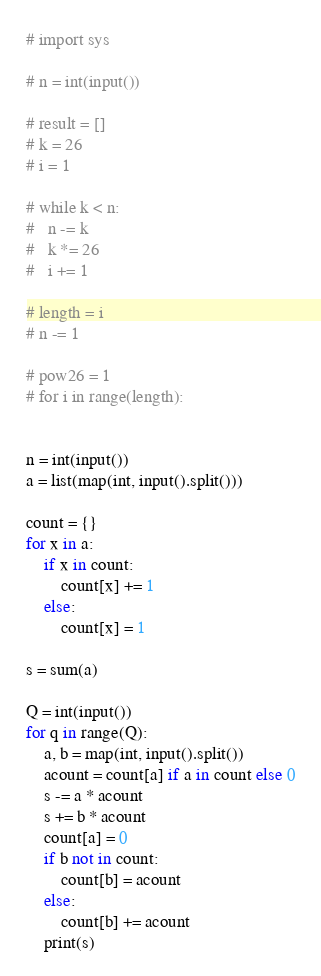<code> <loc_0><loc_0><loc_500><loc_500><_Python_># import sys

# n = int(input())

# result = []
# k = 26
# i = 1

# while k < n:
# 	n -= k
# 	k *= 26
# 	i += 1

# length = i
# n -= 1

# pow26 = 1
# for i in range(length):


n = int(input())
a = list(map(int, input().split()))

count = {}
for x in a:
	if x in count:
		count[x] += 1
	else:
		count[x] = 1

s = sum(a)

Q = int(input())
for q in range(Q):
	a, b = map(int, input().split())
	acount = count[a] if a in count else 0
	s -= a * acount 
	s += b * acount
	count[a] = 0
	if b not in count:
		count[b] = acount
	else:
		count[b] += acount
	print(s)
</code> 